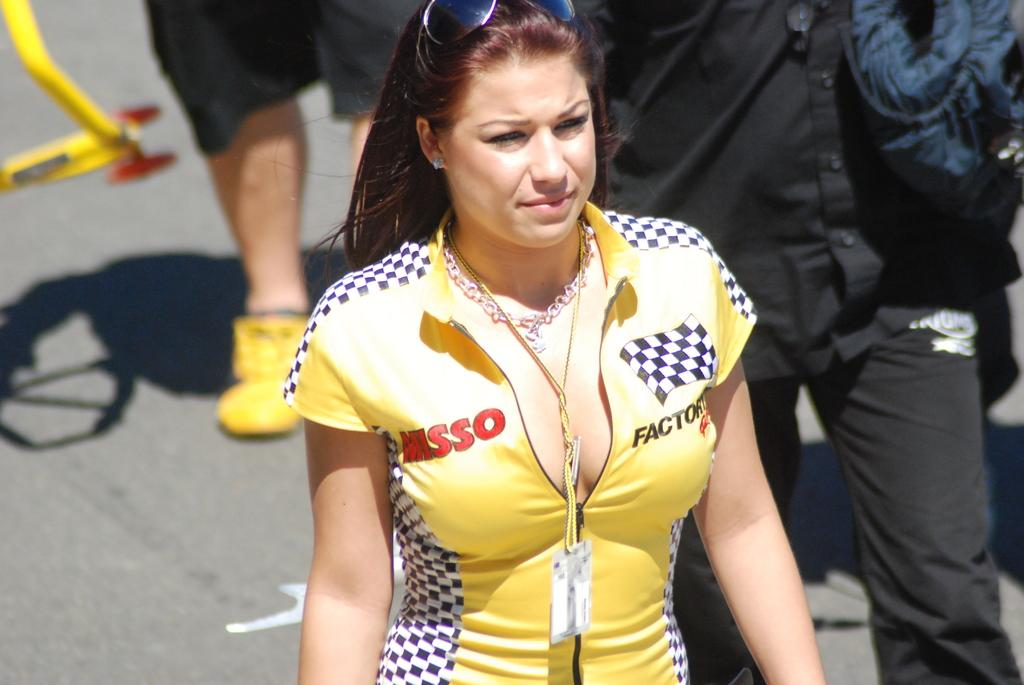<image>
Present a compact description of the photo's key features. A woman is wearing a shirt that says MISSO on it. 